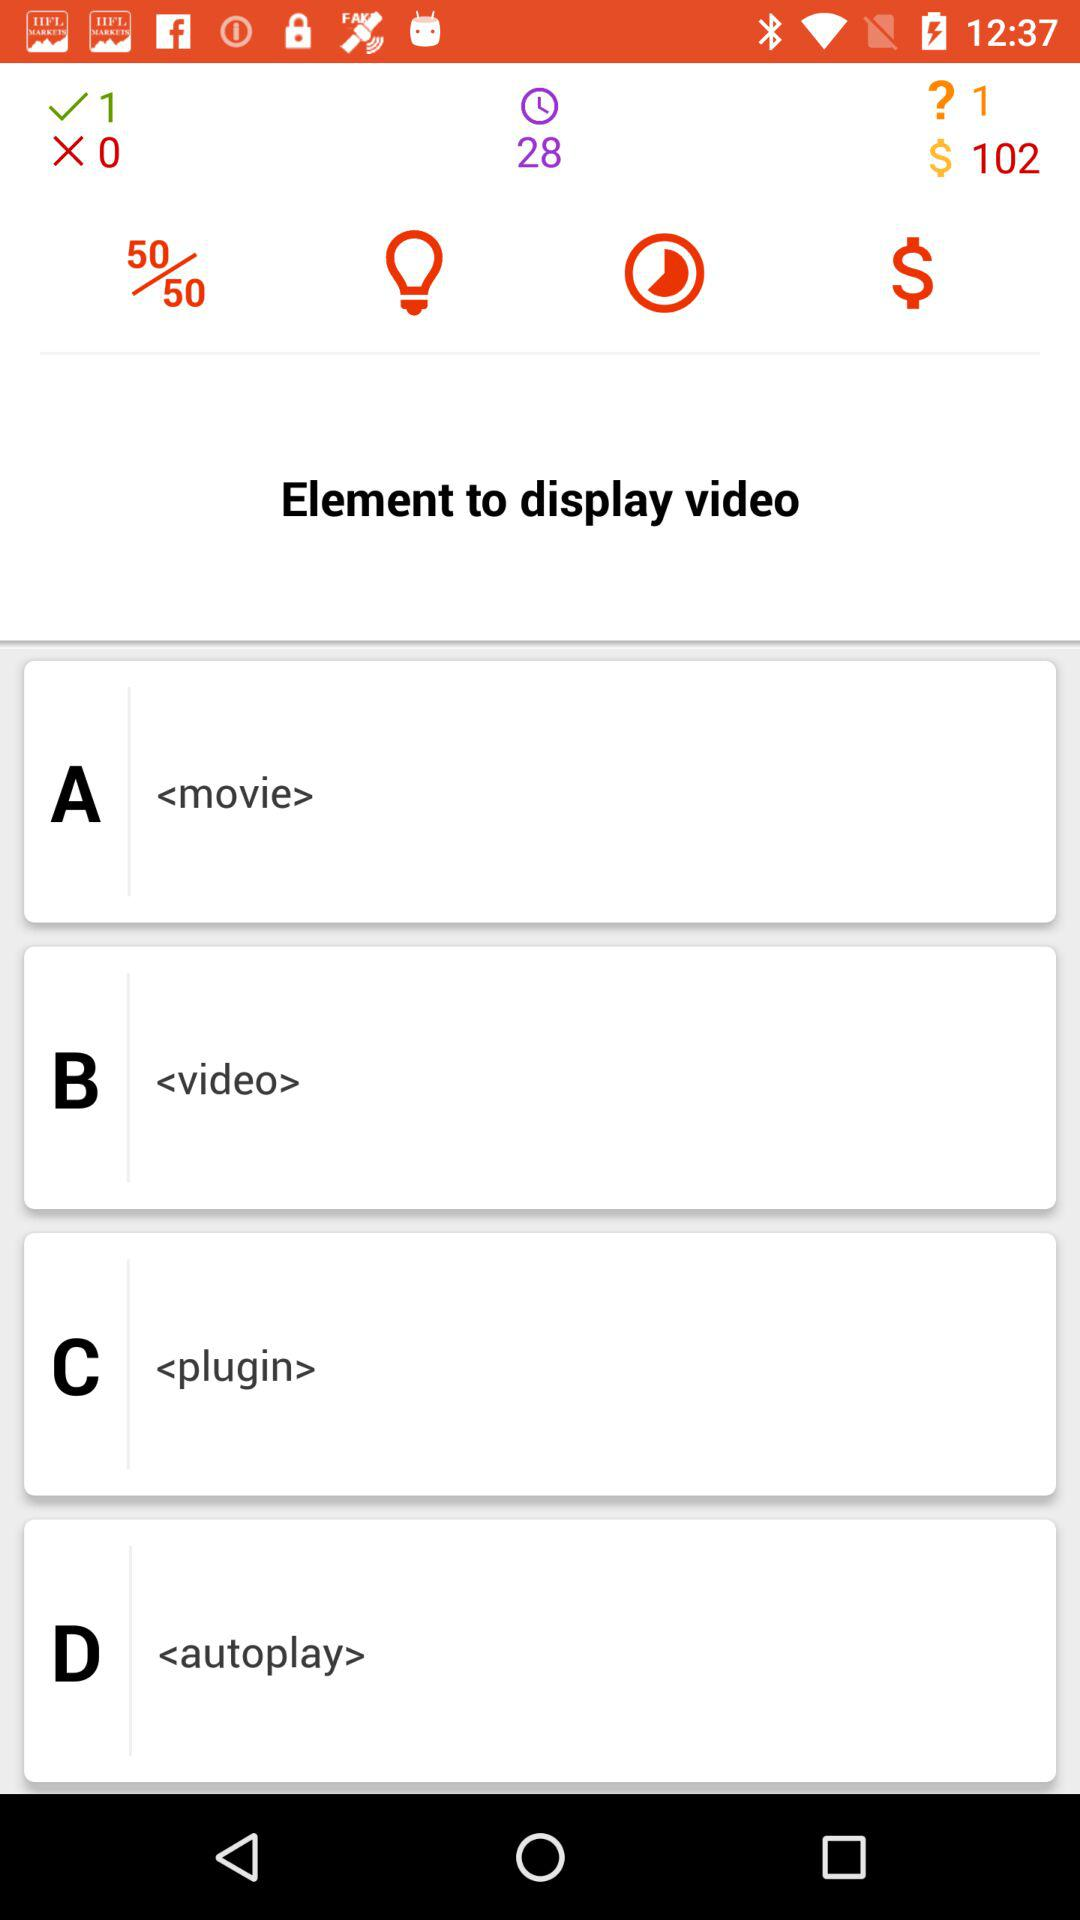What are the options for "Element to display video"? The options are "<movie>", "<video>", "<plugin>" and "<autoplay>". 